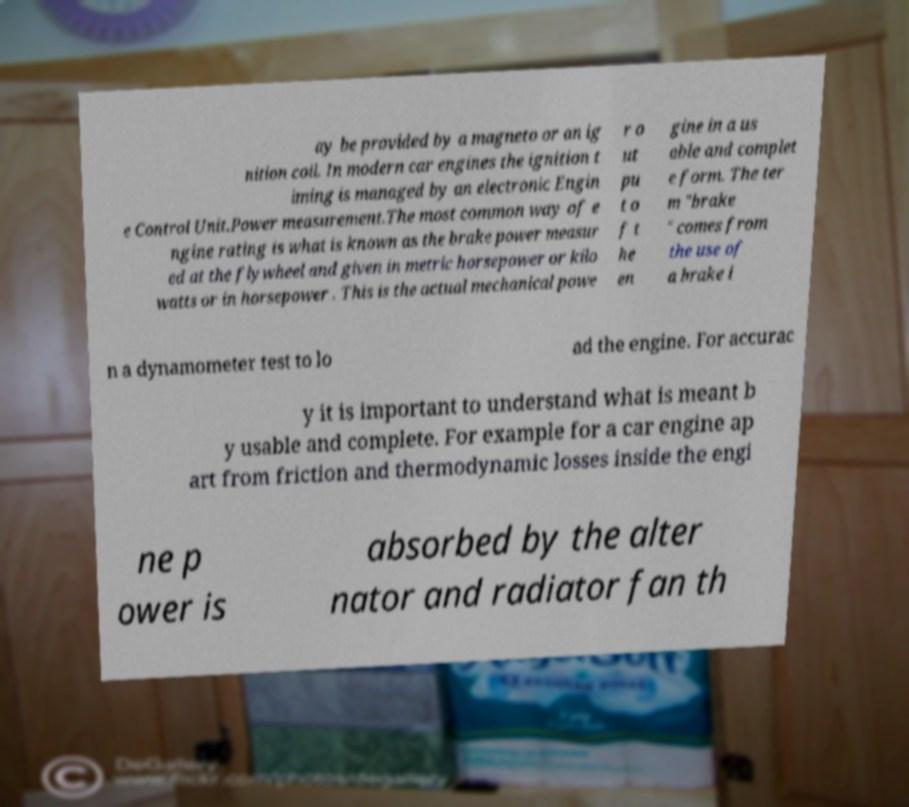Could you extract and type out the text from this image? ay be provided by a magneto or an ig nition coil. In modern car engines the ignition t iming is managed by an electronic Engin e Control Unit.Power measurement.The most common way of e ngine rating is what is known as the brake power measur ed at the flywheel and given in metric horsepower or kilo watts or in horsepower . This is the actual mechanical powe r o ut pu t o f t he en gine in a us able and complet e form. The ter m "brake " comes from the use of a brake i n a dynamometer test to lo ad the engine. For accurac y it is important to understand what is meant b y usable and complete. For example for a car engine ap art from friction and thermodynamic losses inside the engi ne p ower is absorbed by the alter nator and radiator fan th 